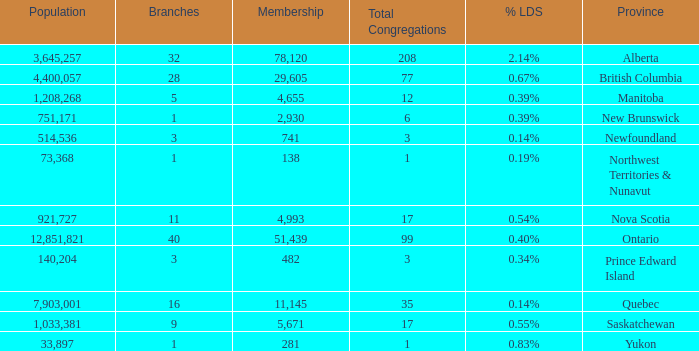What's the sum of population when the membership is 51,439 for fewer than 40 branches? None. 